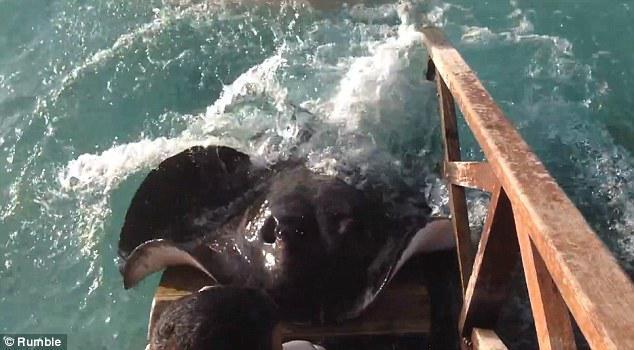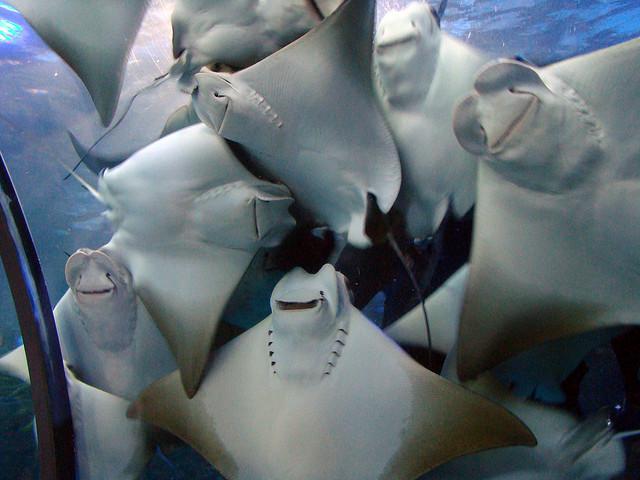The first image is the image on the left, the second image is the image on the right. Assess this claim about the two images: "In one of the images, a human hand is interacting with a fish.". Correct or not? Answer yes or no. No. The first image is the image on the left, the second image is the image on the right. For the images shown, is this caption "A person is hand feeding a marine animal." true? Answer yes or no. No. 